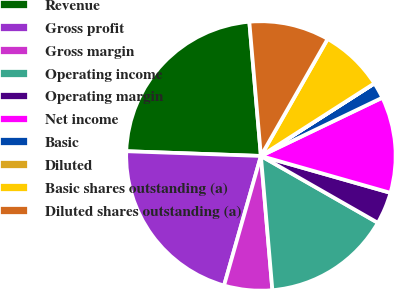Convert chart to OTSL. <chart><loc_0><loc_0><loc_500><loc_500><pie_chart><fcel>Revenue<fcel>Gross profit<fcel>Gross margin<fcel>Operating income<fcel>Operating margin<fcel>Net income<fcel>Basic<fcel>Diluted<fcel>Basic shares outstanding (a)<fcel>Diluted shares outstanding (a)<nl><fcel>23.07%<fcel>21.15%<fcel>5.77%<fcel>15.38%<fcel>3.85%<fcel>11.54%<fcel>1.93%<fcel>0.01%<fcel>7.69%<fcel>9.62%<nl></chart> 